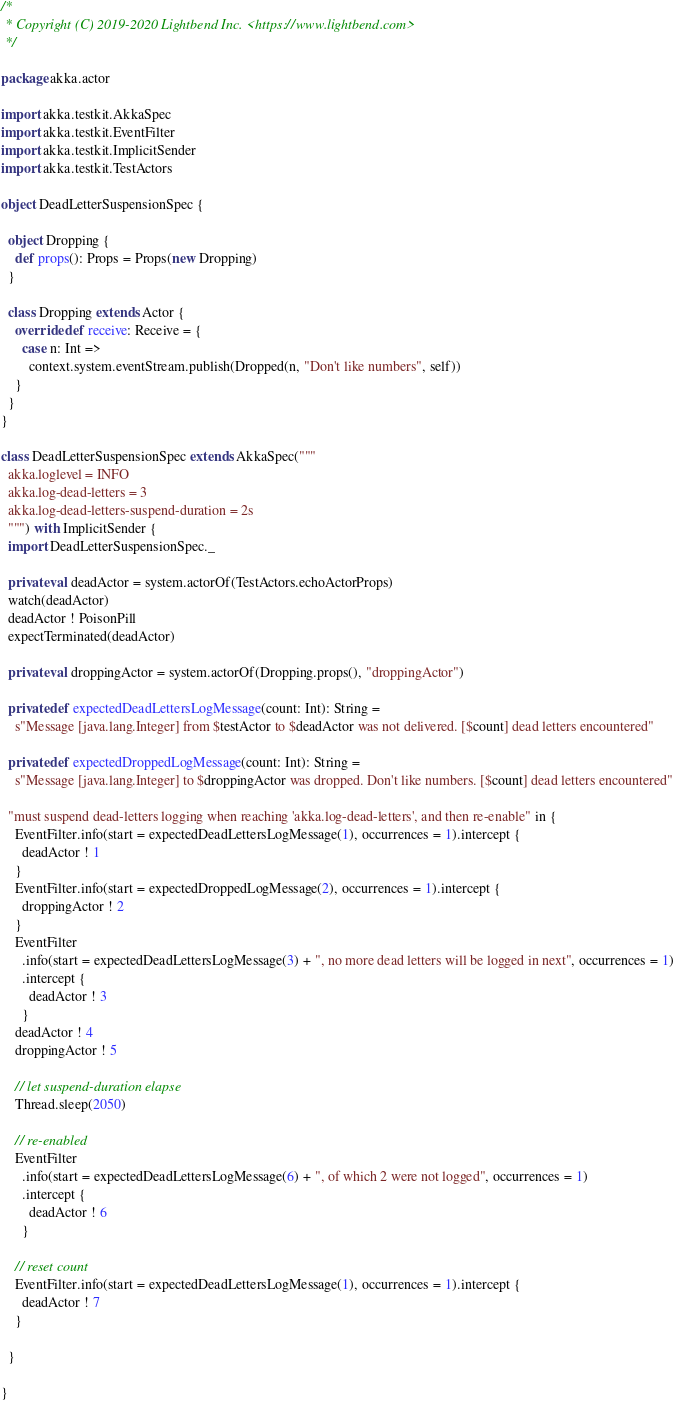<code> <loc_0><loc_0><loc_500><loc_500><_Scala_>/*
 * Copyright (C) 2019-2020 Lightbend Inc. <https://www.lightbend.com>
 */

package akka.actor

import akka.testkit.AkkaSpec
import akka.testkit.EventFilter
import akka.testkit.ImplicitSender
import akka.testkit.TestActors

object DeadLetterSuspensionSpec {

  object Dropping {
    def props(): Props = Props(new Dropping)
  }

  class Dropping extends Actor {
    override def receive: Receive = {
      case n: Int =>
        context.system.eventStream.publish(Dropped(n, "Don't like numbers", self))
    }
  }
}

class DeadLetterSuspensionSpec extends AkkaSpec("""
  akka.loglevel = INFO
  akka.log-dead-letters = 3
  akka.log-dead-letters-suspend-duration = 2s
  """) with ImplicitSender {
  import DeadLetterSuspensionSpec._

  private val deadActor = system.actorOf(TestActors.echoActorProps)
  watch(deadActor)
  deadActor ! PoisonPill
  expectTerminated(deadActor)

  private val droppingActor = system.actorOf(Dropping.props(), "droppingActor")

  private def expectedDeadLettersLogMessage(count: Int): String =
    s"Message [java.lang.Integer] from $testActor to $deadActor was not delivered. [$count] dead letters encountered"

  private def expectedDroppedLogMessage(count: Int): String =
    s"Message [java.lang.Integer] to $droppingActor was dropped. Don't like numbers. [$count] dead letters encountered"

  "must suspend dead-letters logging when reaching 'akka.log-dead-letters', and then re-enable" in {
    EventFilter.info(start = expectedDeadLettersLogMessage(1), occurrences = 1).intercept {
      deadActor ! 1
    }
    EventFilter.info(start = expectedDroppedLogMessage(2), occurrences = 1).intercept {
      droppingActor ! 2
    }
    EventFilter
      .info(start = expectedDeadLettersLogMessage(3) + ", no more dead letters will be logged in next", occurrences = 1)
      .intercept {
        deadActor ! 3
      }
    deadActor ! 4
    droppingActor ! 5

    // let suspend-duration elapse
    Thread.sleep(2050)

    // re-enabled
    EventFilter
      .info(start = expectedDeadLettersLogMessage(6) + ", of which 2 were not logged", occurrences = 1)
      .intercept {
        deadActor ! 6
      }

    // reset count
    EventFilter.info(start = expectedDeadLettersLogMessage(1), occurrences = 1).intercept {
      deadActor ! 7
    }

  }

}
</code> 